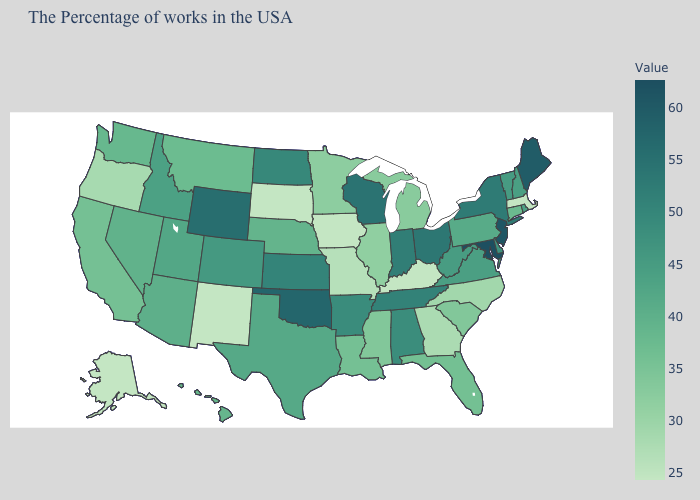Which states have the lowest value in the Northeast?
Answer briefly. Massachusetts. Among the states that border New Jersey , does New York have the lowest value?
Quick response, please. No. Among the states that border Colorado , which have the lowest value?
Be succinct. New Mexico. Does Illinois have a lower value than Missouri?
Short answer required. No. Does Louisiana have a higher value than New Hampshire?
Concise answer only. No. 